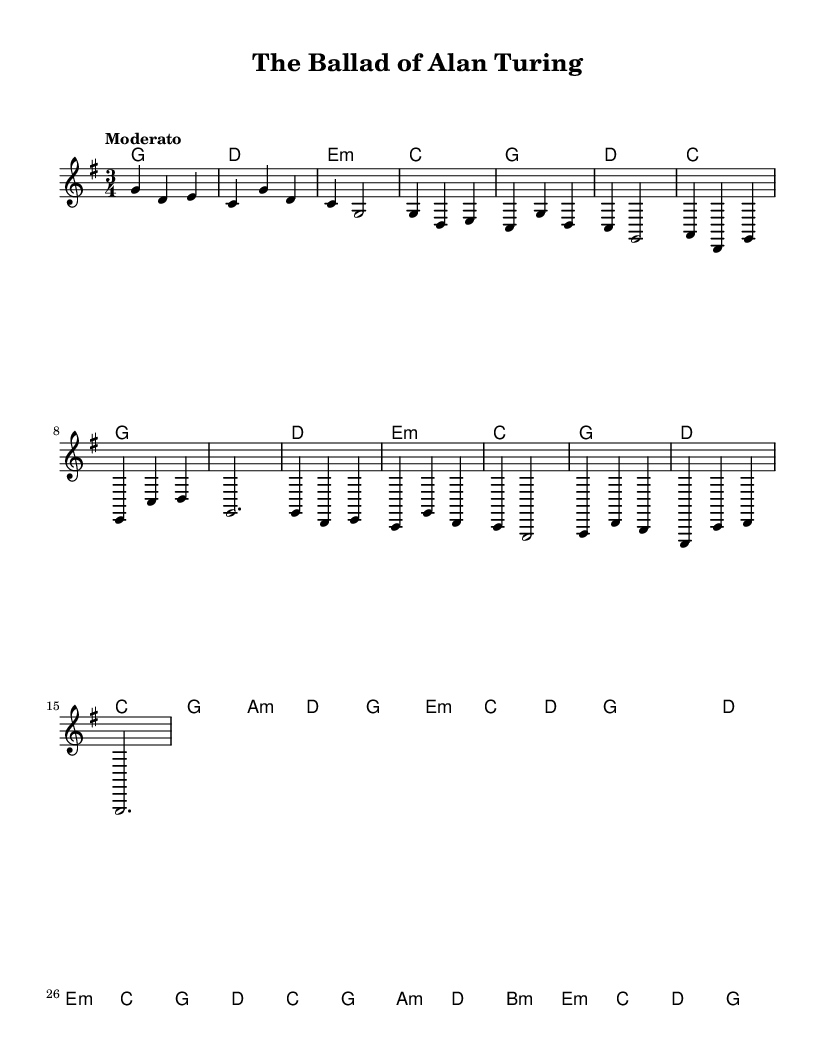What is the key signature of this music? The key signature is G major, which has one sharp (F#).
Answer: G major What is the time signature of this music? The time signature is 3/4, indicating three beats per measure with a quarter note getting one beat.
Answer: 3/4 What is the tempo marking for this piece? The tempo marking is "Moderato", which suggests a moderate speed for playing the music.
Answer: Moderato How many measures are there in the chorus section? The chorus section consists of four measures, as indicated by the grouping of musical phrases.
Answer: 4 What is the harmonic progression used in the first measure? The harmonic progression in the first measure is G major chord, which is the root chord of the piece and establishes the tonic.
Answer: G What is the thematic focus of the lyrics in folk ballads like this one? Folk ballads often chronicle the lives and contributions of notable individuals, blending storytelling with musical elements.
Answer: Lives of famous computer scientists What type of musical texture is mostly used in this folk ballad? The music primarily features a homophonic texture, where the melody is accompanied by chords that support it harmonically.
Answer: Homophonic 